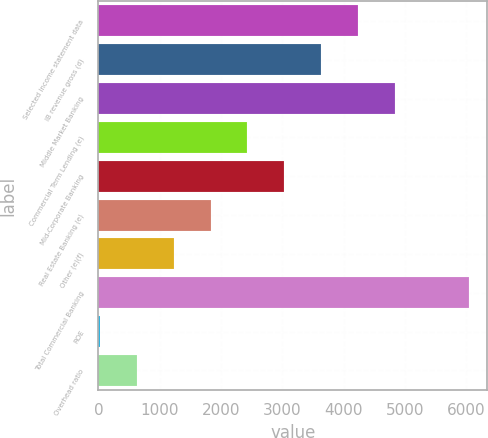<chart> <loc_0><loc_0><loc_500><loc_500><bar_chart><fcel>Selected income statement data<fcel>IB revenue gross (d)<fcel>Middle Market Banking<fcel>Commercial Term Lending (e)<fcel>Mid-Corporate Banking<fcel>Real Estate Banking (e)<fcel>Other (e)(f)<fcel>Total Commercial Banking<fcel>ROE<fcel>Overhead ratio<nl><fcel>4235.8<fcel>3634.4<fcel>4837.2<fcel>2431.6<fcel>3033<fcel>1830.2<fcel>1228.8<fcel>6040<fcel>26<fcel>627.4<nl></chart> 